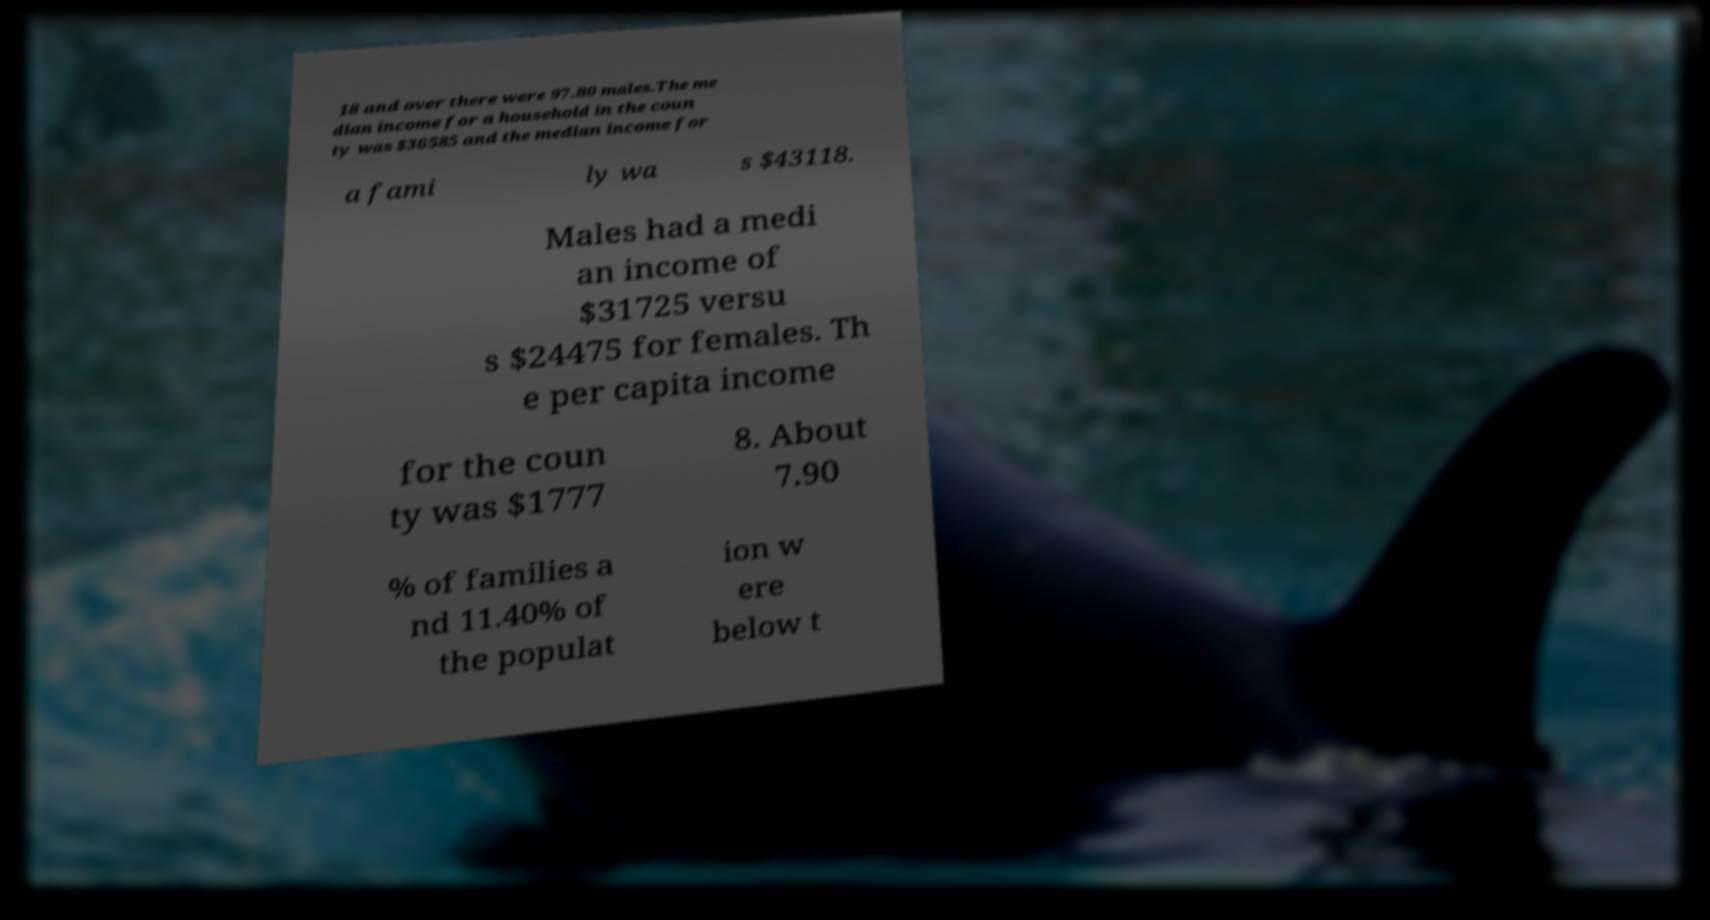Could you assist in decoding the text presented in this image and type it out clearly? 18 and over there were 97.80 males.The me dian income for a household in the coun ty was $36585 and the median income for a fami ly wa s $43118. Males had a medi an income of $31725 versu s $24475 for females. Th e per capita income for the coun ty was $1777 8. About 7.90 % of families a nd 11.40% of the populat ion w ere below t 